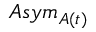Convert formula to latex. <formula><loc_0><loc_0><loc_500><loc_500>A s y m _ { A ( t ) }</formula> 